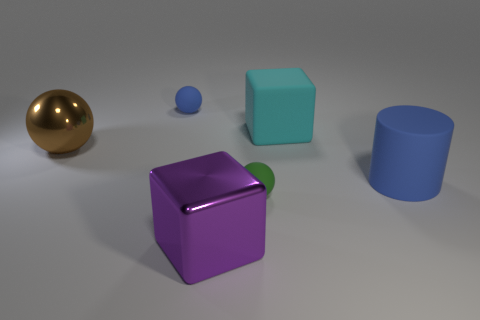There is a big rubber cylinder; is its color the same as the small matte sphere left of the green thing?
Provide a short and direct response. Yes. There is a tiny rubber sphere behind the big cyan rubber object; does it have the same color as the cylinder?
Your answer should be compact. Yes. Are there fewer brown objects that are behind the large brown metallic sphere than large blue matte cubes?
Give a very brief answer. No. There is a tiny object that is the same color as the large cylinder; what shape is it?
Offer a terse response. Sphere. What number of cubes have the same size as the blue rubber cylinder?
Offer a very short reply. 2. There is a blue matte object that is to the right of the green rubber ball; what is its shape?
Give a very brief answer. Cylinder. Are there fewer large cylinders than small rubber spheres?
Ensure brevity in your answer.  Yes. Are there any other things that are the same color as the big sphere?
Keep it short and to the point. No. How big is the blue matte object that is on the left side of the large blue matte object?
Offer a terse response. Small. Are there more large brown objects than tiny blue matte cubes?
Make the answer very short. Yes. 